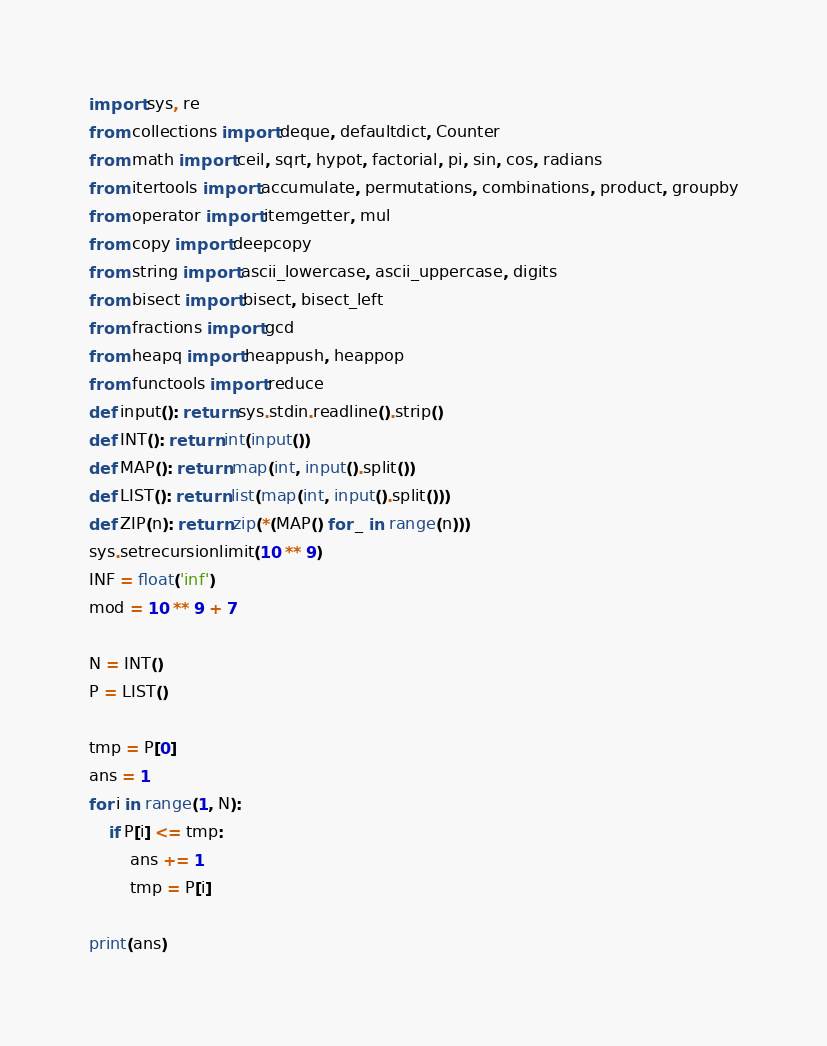<code> <loc_0><loc_0><loc_500><loc_500><_Python_>import sys, re
from collections import deque, defaultdict, Counter
from math import ceil, sqrt, hypot, factorial, pi, sin, cos, radians
from itertools import accumulate, permutations, combinations, product, groupby
from operator import itemgetter, mul
from copy import deepcopy
from string import ascii_lowercase, ascii_uppercase, digits
from bisect import bisect, bisect_left
from fractions import gcd
from heapq import heappush, heappop
from functools import reduce
def input(): return sys.stdin.readline().strip()
def INT(): return int(input())
def MAP(): return map(int, input().split())
def LIST(): return list(map(int, input().split()))
def ZIP(n): return zip(*(MAP() for _ in range(n)))
sys.setrecursionlimit(10 ** 9)
INF = float('inf')
mod = 10 ** 9 + 7

N = INT()
P = LIST()

tmp = P[0]
ans = 1
for i in range(1, N):
	if P[i] <= tmp:
		ans += 1
		tmp = P[i]

print(ans)</code> 